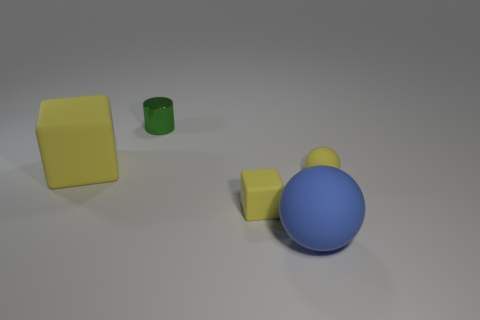What material is the tiny sphere that is the same color as the big block?
Your answer should be very brief. Rubber. Is the big blue ball made of the same material as the tiny yellow ball?
Keep it short and to the point. Yes. What number of green objects are made of the same material as the small yellow block?
Your answer should be compact. 0. What is the color of the block that is made of the same material as the large yellow object?
Your answer should be compact. Yellow. The blue matte thing has what shape?
Give a very brief answer. Sphere. What is the material of the yellow thing that is on the right side of the blue object?
Your answer should be very brief. Rubber. Is there a small rubber object that has the same color as the small rubber cube?
Your response must be concise. Yes. What is the shape of the yellow rubber object that is the same size as the yellow sphere?
Offer a terse response. Cube. What color is the rubber ball that is left of the tiny rubber ball?
Your response must be concise. Blue. Are there any tiny yellow objects that are in front of the matte ball that is behind the blue ball?
Provide a short and direct response. Yes. 